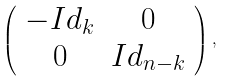Convert formula to latex. <formula><loc_0><loc_0><loc_500><loc_500>\left ( \begin{array} { c c } - I d _ { k } & 0 \\ 0 & I d _ { n - k } \end{array} \right ) ,</formula> 